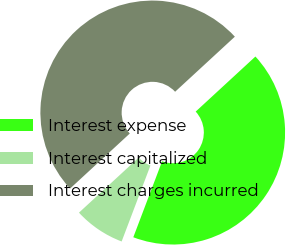Convert chart to OTSL. <chart><loc_0><loc_0><loc_500><loc_500><pie_chart><fcel>Interest expense<fcel>Interest capitalized<fcel>Interest charges incurred<nl><fcel>42.62%<fcel>7.38%<fcel>50.0%<nl></chart> 